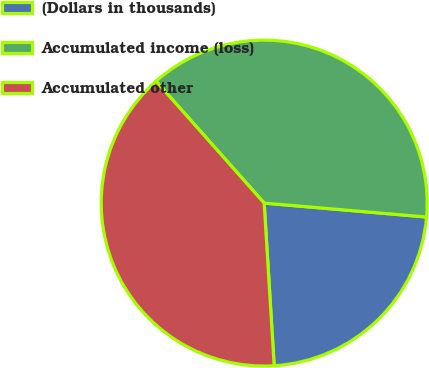Convert chart. <chart><loc_0><loc_0><loc_500><loc_500><pie_chart><fcel>(Dollars in thousands)<fcel>Accumulated income (loss)<fcel>Accumulated other<nl><fcel>22.66%<fcel>37.91%<fcel>39.43%<nl></chart> 